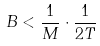<formula> <loc_0><loc_0><loc_500><loc_500>B < \frac { 1 } { M } \cdot \frac { 1 } { 2 T }</formula> 